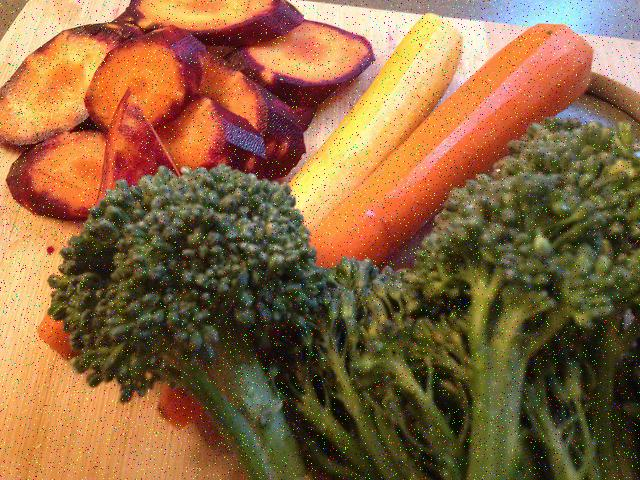Suggest a meal or dish that could include these vegetables. These vibrant vegetables could be turned into a nourishing roasted vegetable dish. Lightly coating them with olive oil, seasoning with a touch of salt, pepper, and garlic powder, and then roasting them in an oven until they're tender and slightly caramelized would augment their natural flavors. They could also serve as hearty side dishes or be incorporated into a vegetable stir-fry, complementing grains like quinoa or brown rice. 